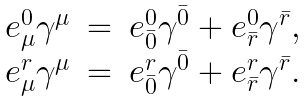Convert formula to latex. <formula><loc_0><loc_0><loc_500><loc_500>\begin{array} { c c c } e ^ { 0 } _ { \mu } \gamma ^ { \mu } & = & e ^ { 0 } _ { \bar { 0 } } \gamma ^ { \bar { 0 } } + e ^ { 0 } _ { \bar { r } } \gamma ^ { \bar { r } } , \\ e ^ { r } _ { \mu } \gamma ^ { \mu } & = & e ^ { r } _ { \bar { 0 } } \gamma ^ { \bar { 0 } } + e ^ { r } _ { \bar { r } } \gamma ^ { \bar { r } } . \end{array}</formula> 